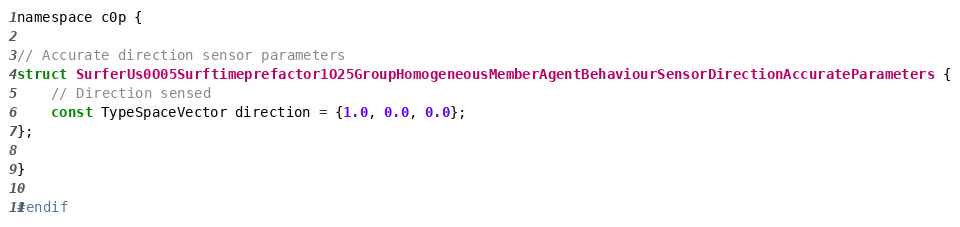Convert code to text. <code><loc_0><loc_0><loc_500><loc_500><_C_>namespace c0p {

// Accurate direction sensor parameters
struct SurferUs0O05Surftimeprefactor1O25GroupHomogeneousMemberAgentBehaviourSensorDirectionAccurateParameters {
    // Direction sensed
    const TypeSpaceVector direction = {1.0, 0.0, 0.0};
};

}

#endif
</code> 